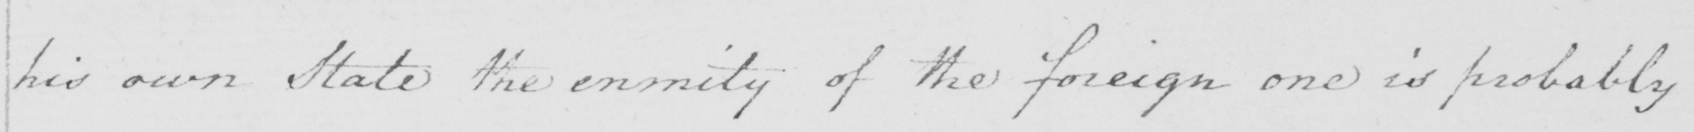Transcribe the text shown in this historical manuscript line. his own State the enmity of the foreign one is probably 